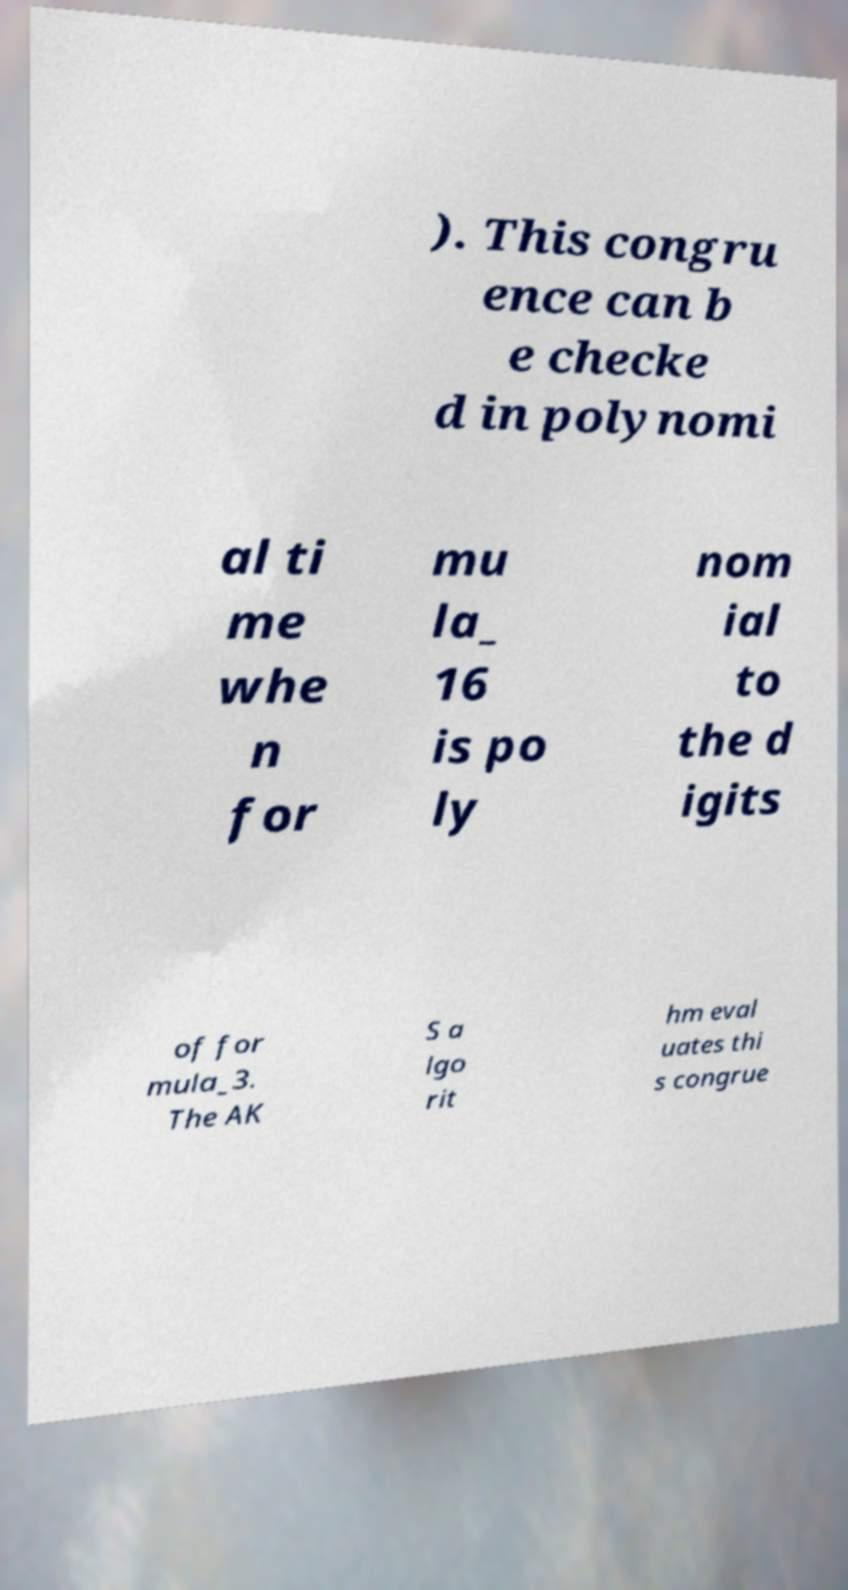Can you read and provide the text displayed in the image?This photo seems to have some interesting text. Can you extract and type it out for me? ). This congru ence can b e checke d in polynomi al ti me whe n for mu la_ 16 is po ly nom ial to the d igits of for mula_3. The AK S a lgo rit hm eval uates thi s congrue 